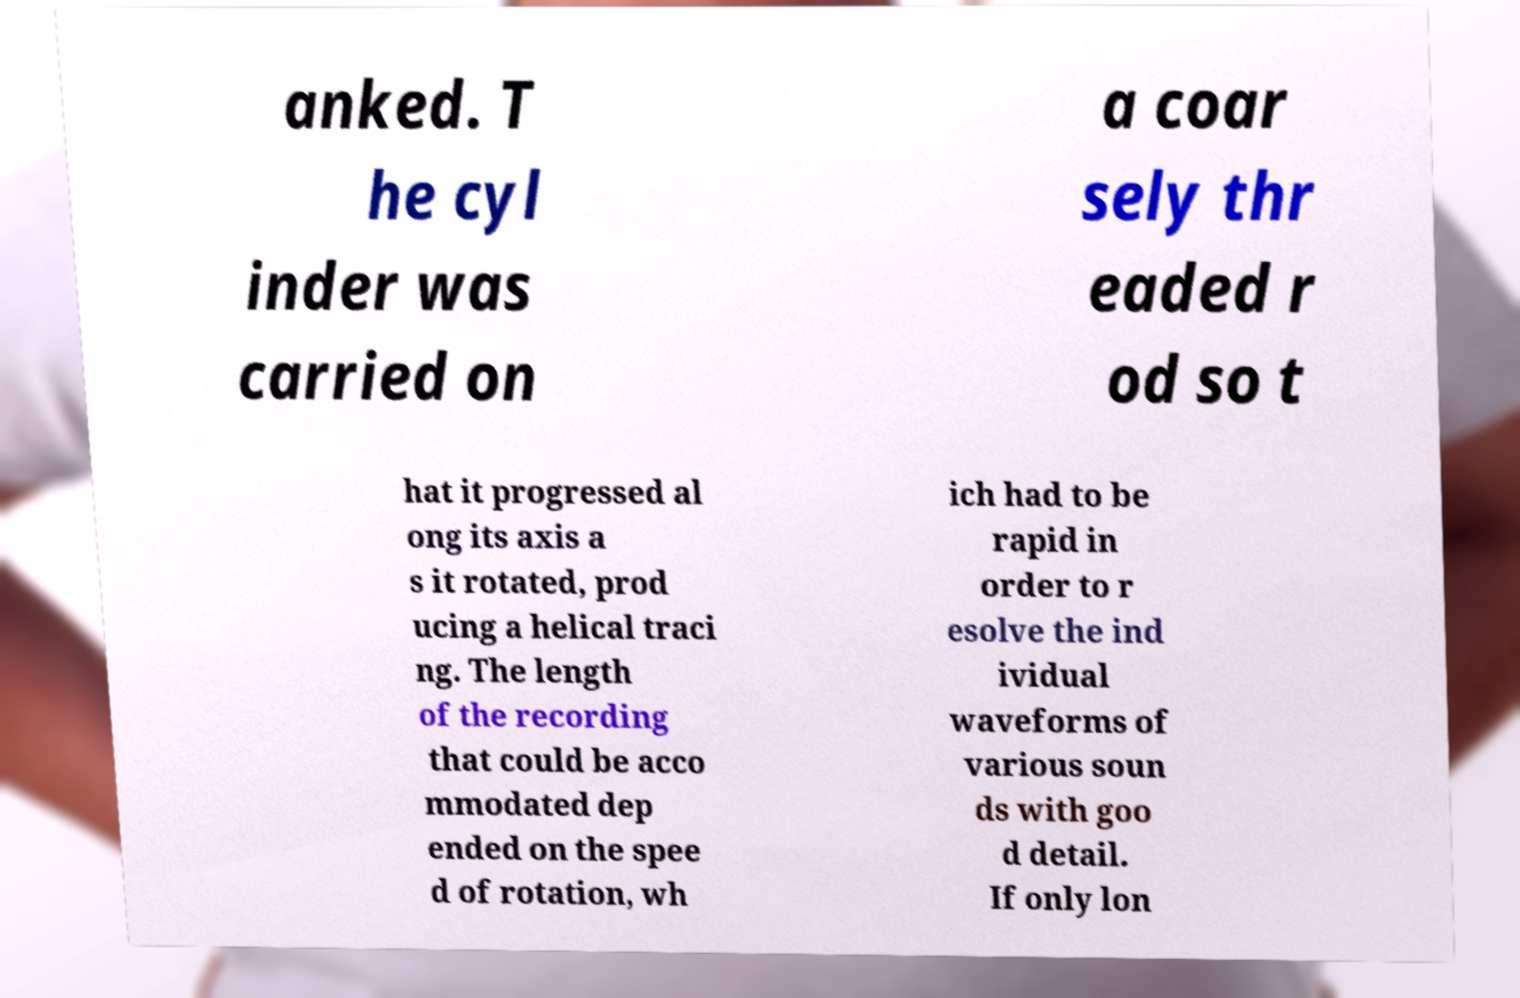I need the written content from this picture converted into text. Can you do that? anked. T he cyl inder was carried on a coar sely thr eaded r od so t hat it progressed al ong its axis a s it rotated, prod ucing a helical traci ng. The length of the recording that could be acco mmodated dep ended on the spee d of rotation, wh ich had to be rapid in order to r esolve the ind ividual waveforms of various soun ds with goo d detail. If only lon 